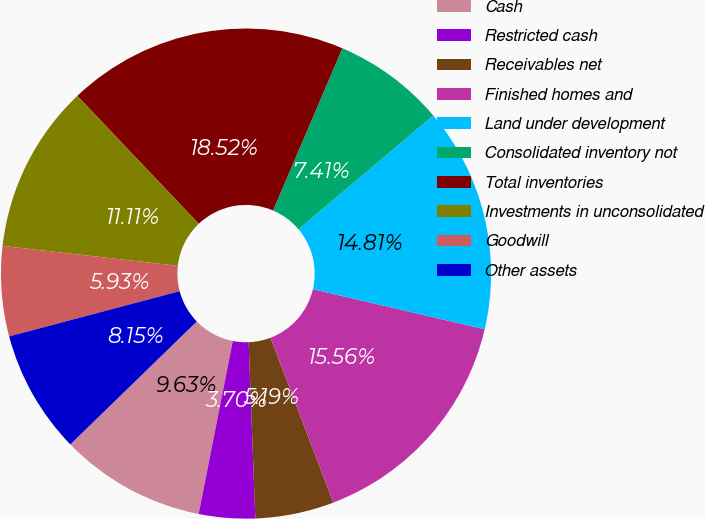<chart> <loc_0><loc_0><loc_500><loc_500><pie_chart><fcel>Cash<fcel>Restricted cash<fcel>Receivables net<fcel>Finished homes and<fcel>Land under development<fcel>Consolidated inventory not<fcel>Total inventories<fcel>Investments in unconsolidated<fcel>Goodwill<fcel>Other assets<nl><fcel>9.63%<fcel>3.7%<fcel>5.19%<fcel>15.56%<fcel>14.81%<fcel>7.41%<fcel>18.52%<fcel>11.11%<fcel>5.93%<fcel>8.15%<nl></chart> 